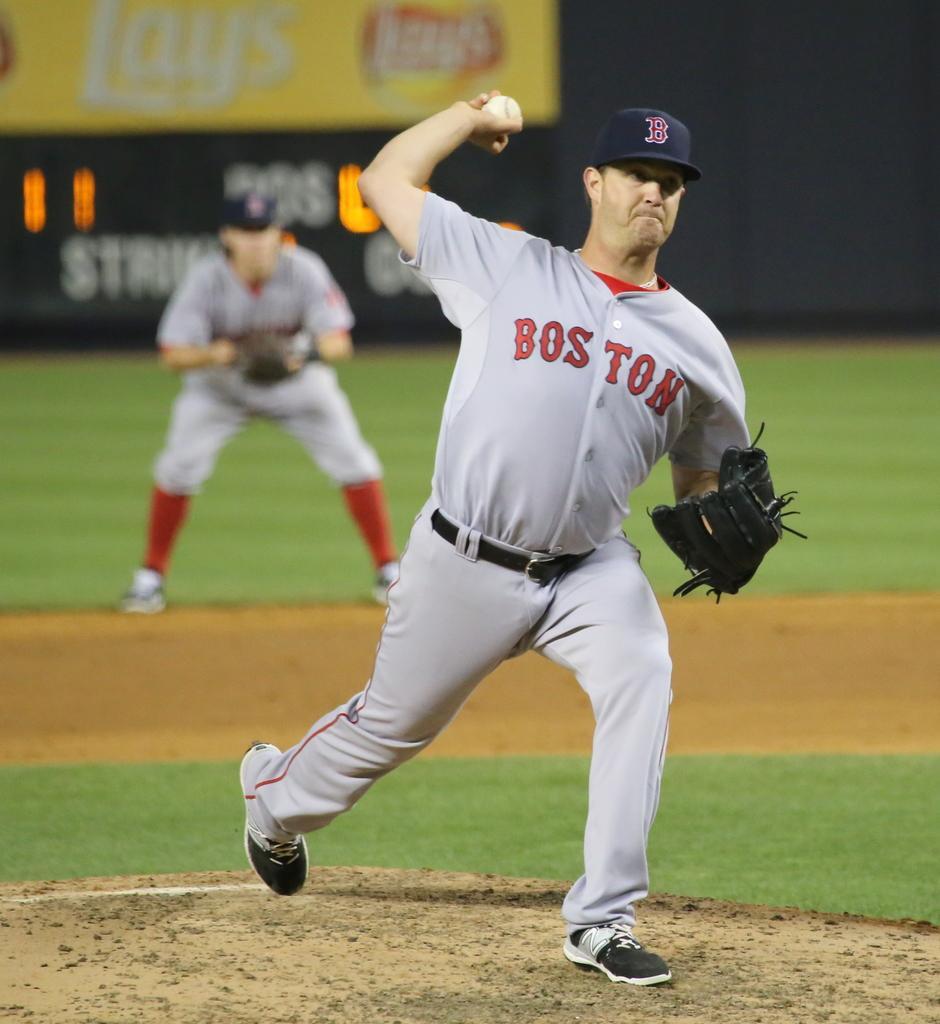Describe this image in one or two sentences. In this image I can see a person wearing grey and red colored jersey and black colored glove is standing and holding a ball in his hand. In the background I can see the ground, a person's standing, the banner and the score board. 